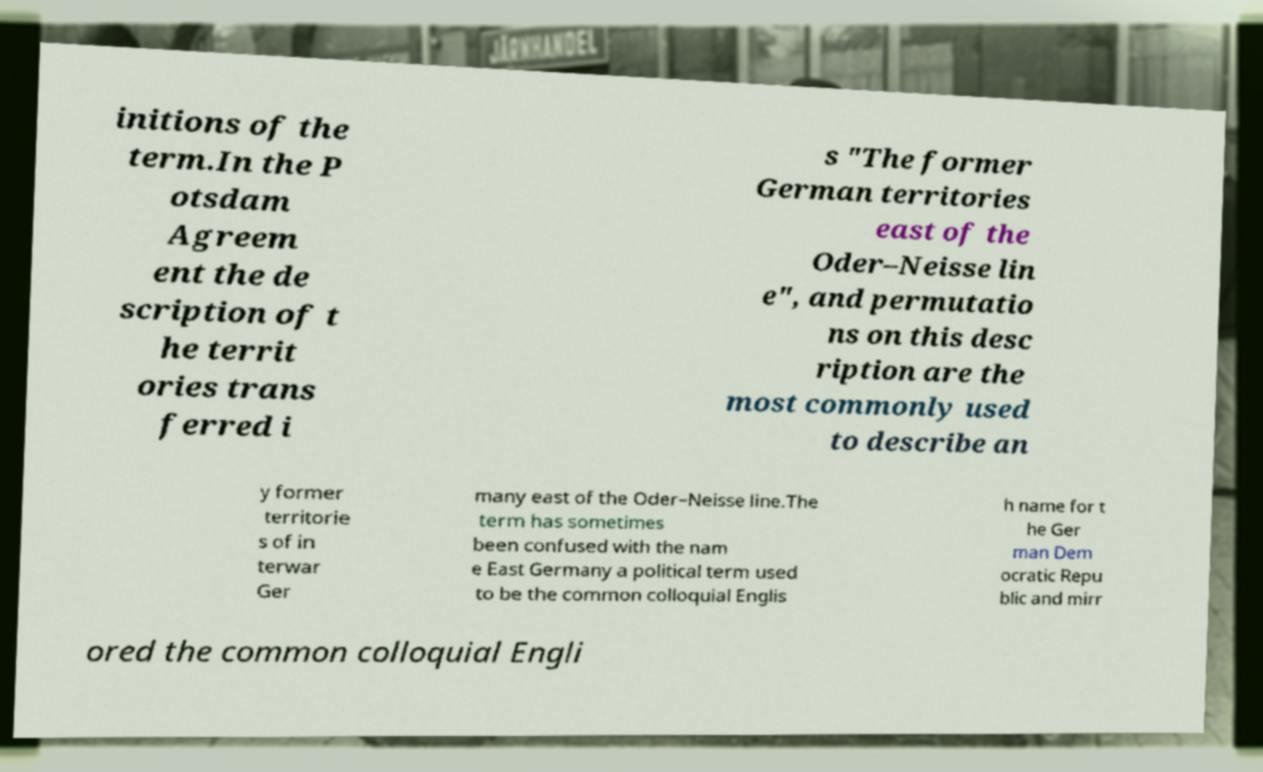Please read and relay the text visible in this image. What does it say? initions of the term.In the P otsdam Agreem ent the de scription of t he territ ories trans ferred i s "The former German territories east of the Oder–Neisse lin e", and permutatio ns on this desc ription are the most commonly used to describe an y former territorie s of in terwar Ger many east of the Oder–Neisse line.The term has sometimes been confused with the nam e East Germany a political term used to be the common colloquial Englis h name for t he Ger man Dem ocratic Repu blic and mirr ored the common colloquial Engli 